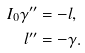Convert formula to latex. <formula><loc_0><loc_0><loc_500><loc_500>I _ { 0 } \gamma ^ { \prime \prime } & = - l , \\ l ^ { \prime \prime } & = - \gamma .</formula> 